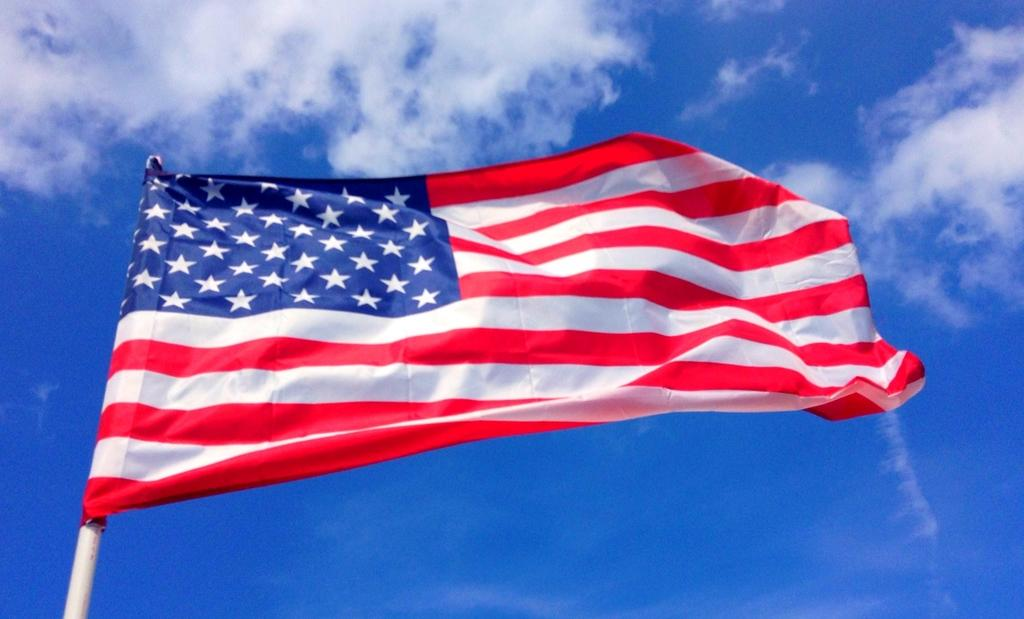What is the main object in the foreground of the image? There is a flag in the image, and it is in the front of the image. What can be seen in the background of the image? There is sky visible in the background of the image. What type of salt is being used to weigh down the flag in the image? There is no salt present in the image, and the flag is not being weighed down. 